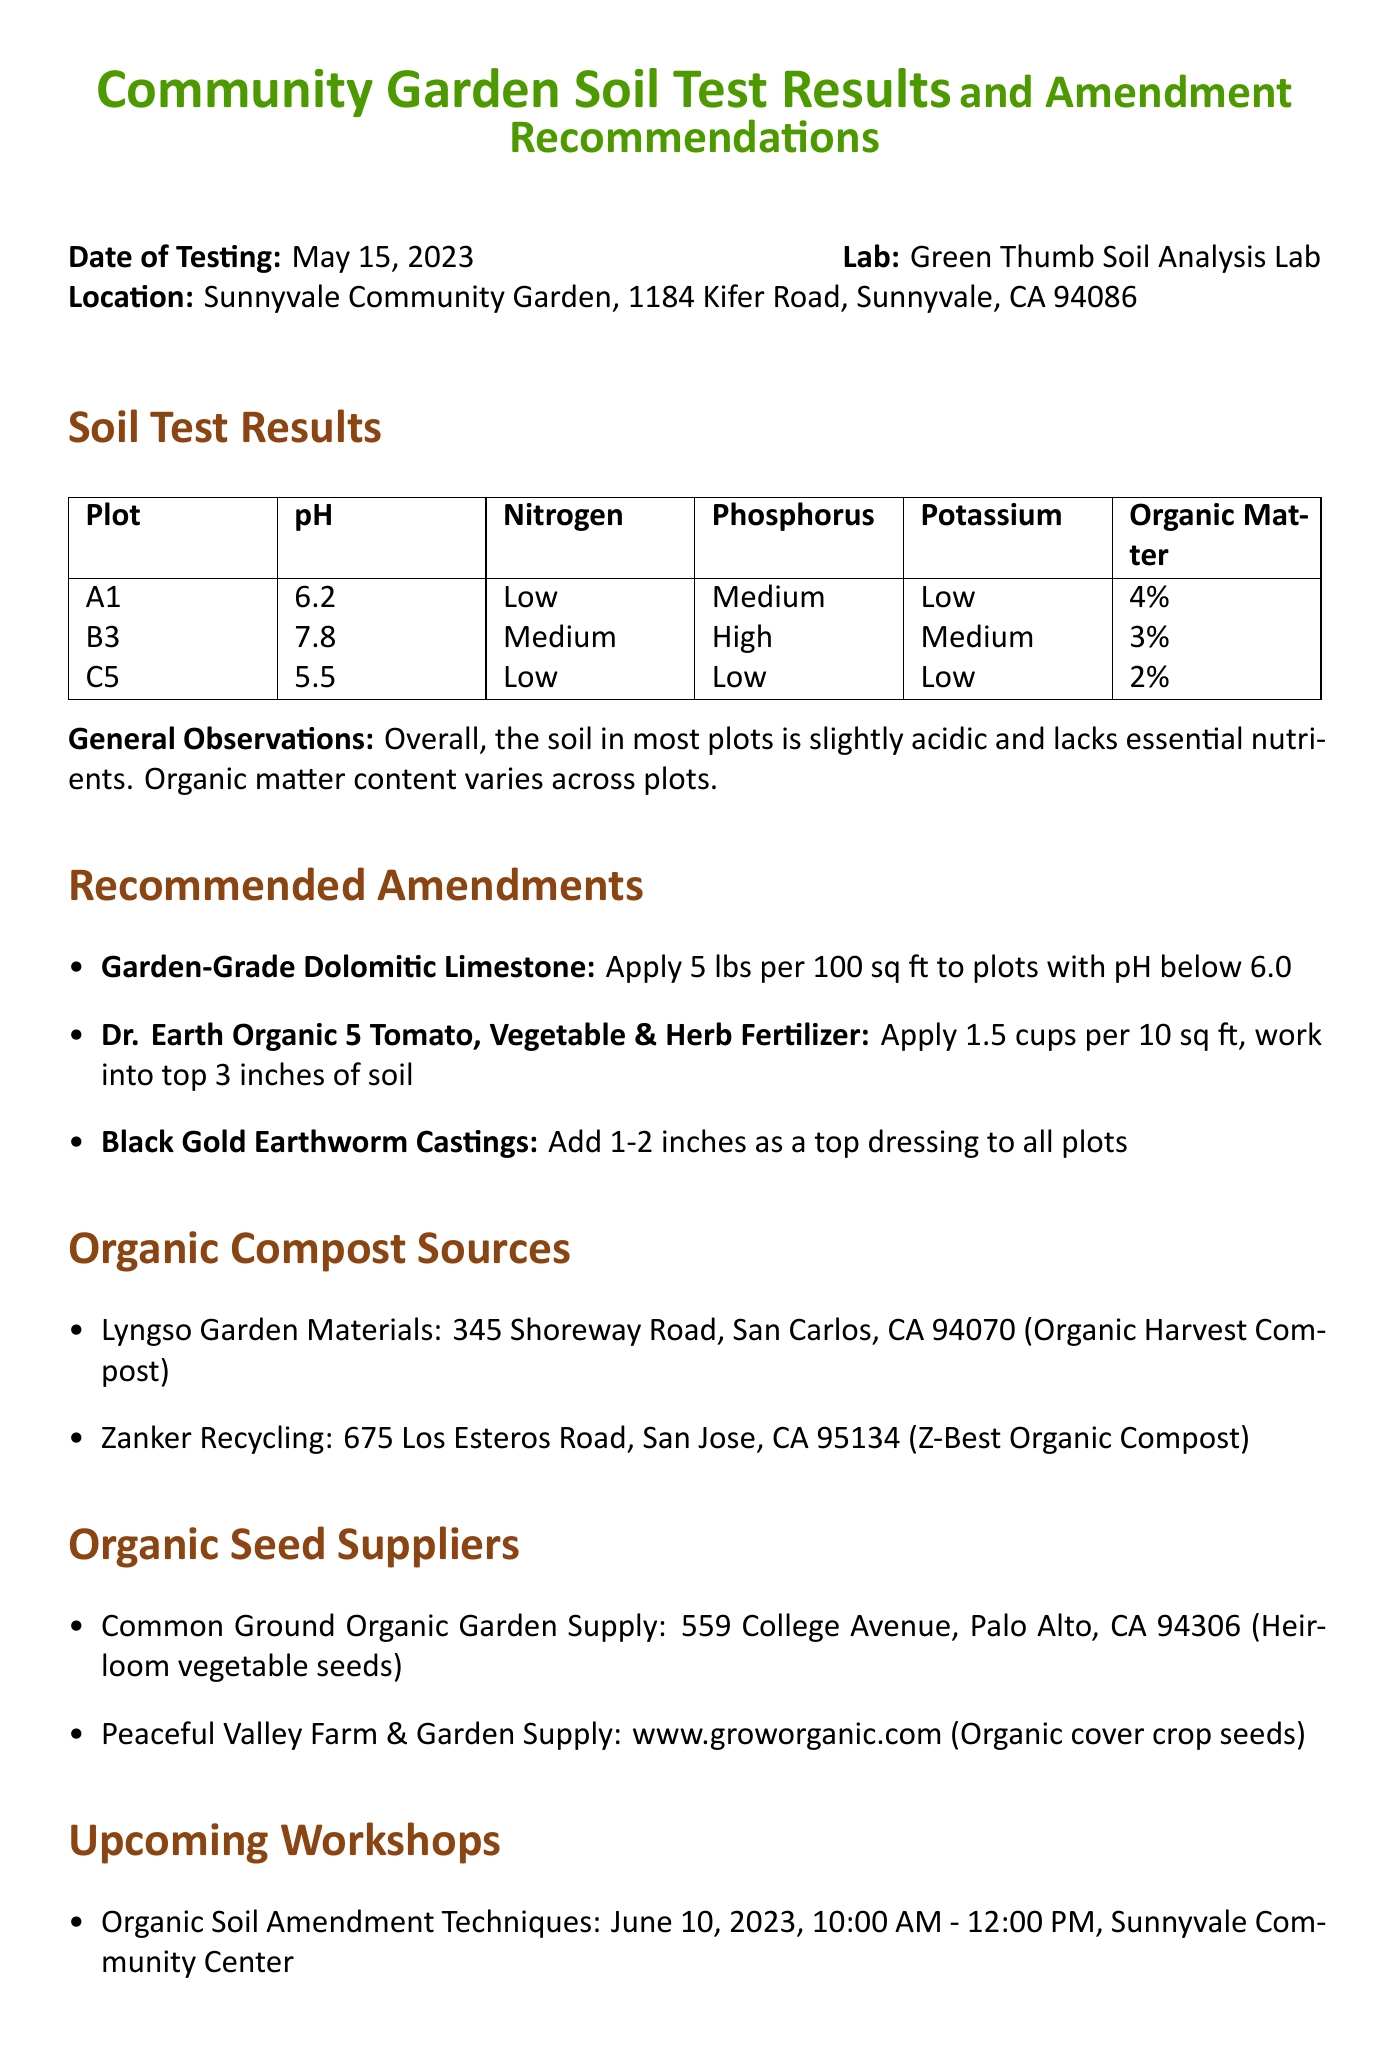What is the date of testing? The date of testing is mentioned in the document as May 15, 2023.
Answer: May 15, 2023 What lab conducted the soil analysis? The name of the lab that conducted the analysis is given in the document as Green Thumb Soil Analysis Lab.
Answer: Green Thumb Soil Analysis Lab Which plot has the lowest pH value? The document lists the pH values for each plot, where plot C5 has the lowest pH at 5.5.
Answer: C5 What is the recommended application for Dr. Earth Organic 5 fertilizer? The application instructions for Dr. Earth Organic 5 fertilizer are specified to apply 1.5 cups per 10 sq ft, working it into the top 3 inches of soil.
Answer: Apply 1.5 cups per 10 sq ft Which amendment is recommended to increase organic matter content? The document identifies Black Gold Earthworm Castings as an amendment to increase organic matter content.
Answer: Black Gold Earthworm Castings What is the purpose of using Garden-Grade Dolomitic Limestone? The purpose of Garden-Grade Dolomitic Limestone is to raise the pH in acidic plots, particularly those with pH below 6.0.
Answer: Raise pH in acidic plots What workshop is scheduled for June 10, 2023? The document lists a workshop titled "Organic Soil Amendment Techniques" scheduled for June 10, 2023.
Answer: Organic Soil Amendment Techniques What is one of the next steps after the soil testing? One of the next steps listed is to schedule a community work day to apply amendments.
Answer: Schedule a community work day 